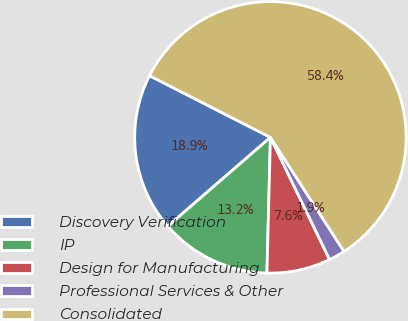<chart> <loc_0><loc_0><loc_500><loc_500><pie_chart><fcel>Discovery Verification<fcel>IP<fcel>Design for Manufacturing<fcel>Professional Services & Other<fcel>Consolidated<nl><fcel>18.87%<fcel>13.23%<fcel>7.59%<fcel>1.94%<fcel>58.37%<nl></chart> 